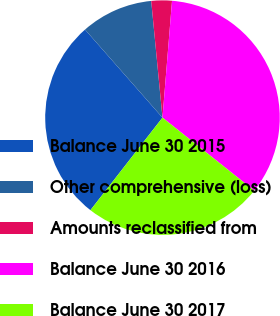<chart> <loc_0><loc_0><loc_500><loc_500><pie_chart><fcel>Balance June 30 2015<fcel>Other comprehensive (loss)<fcel>Amounts reclassified from<fcel>Balance June 30 2016<fcel>Balance June 30 2017<nl><fcel>27.99%<fcel>9.95%<fcel>2.83%<fcel>34.4%<fcel>24.83%<nl></chart> 